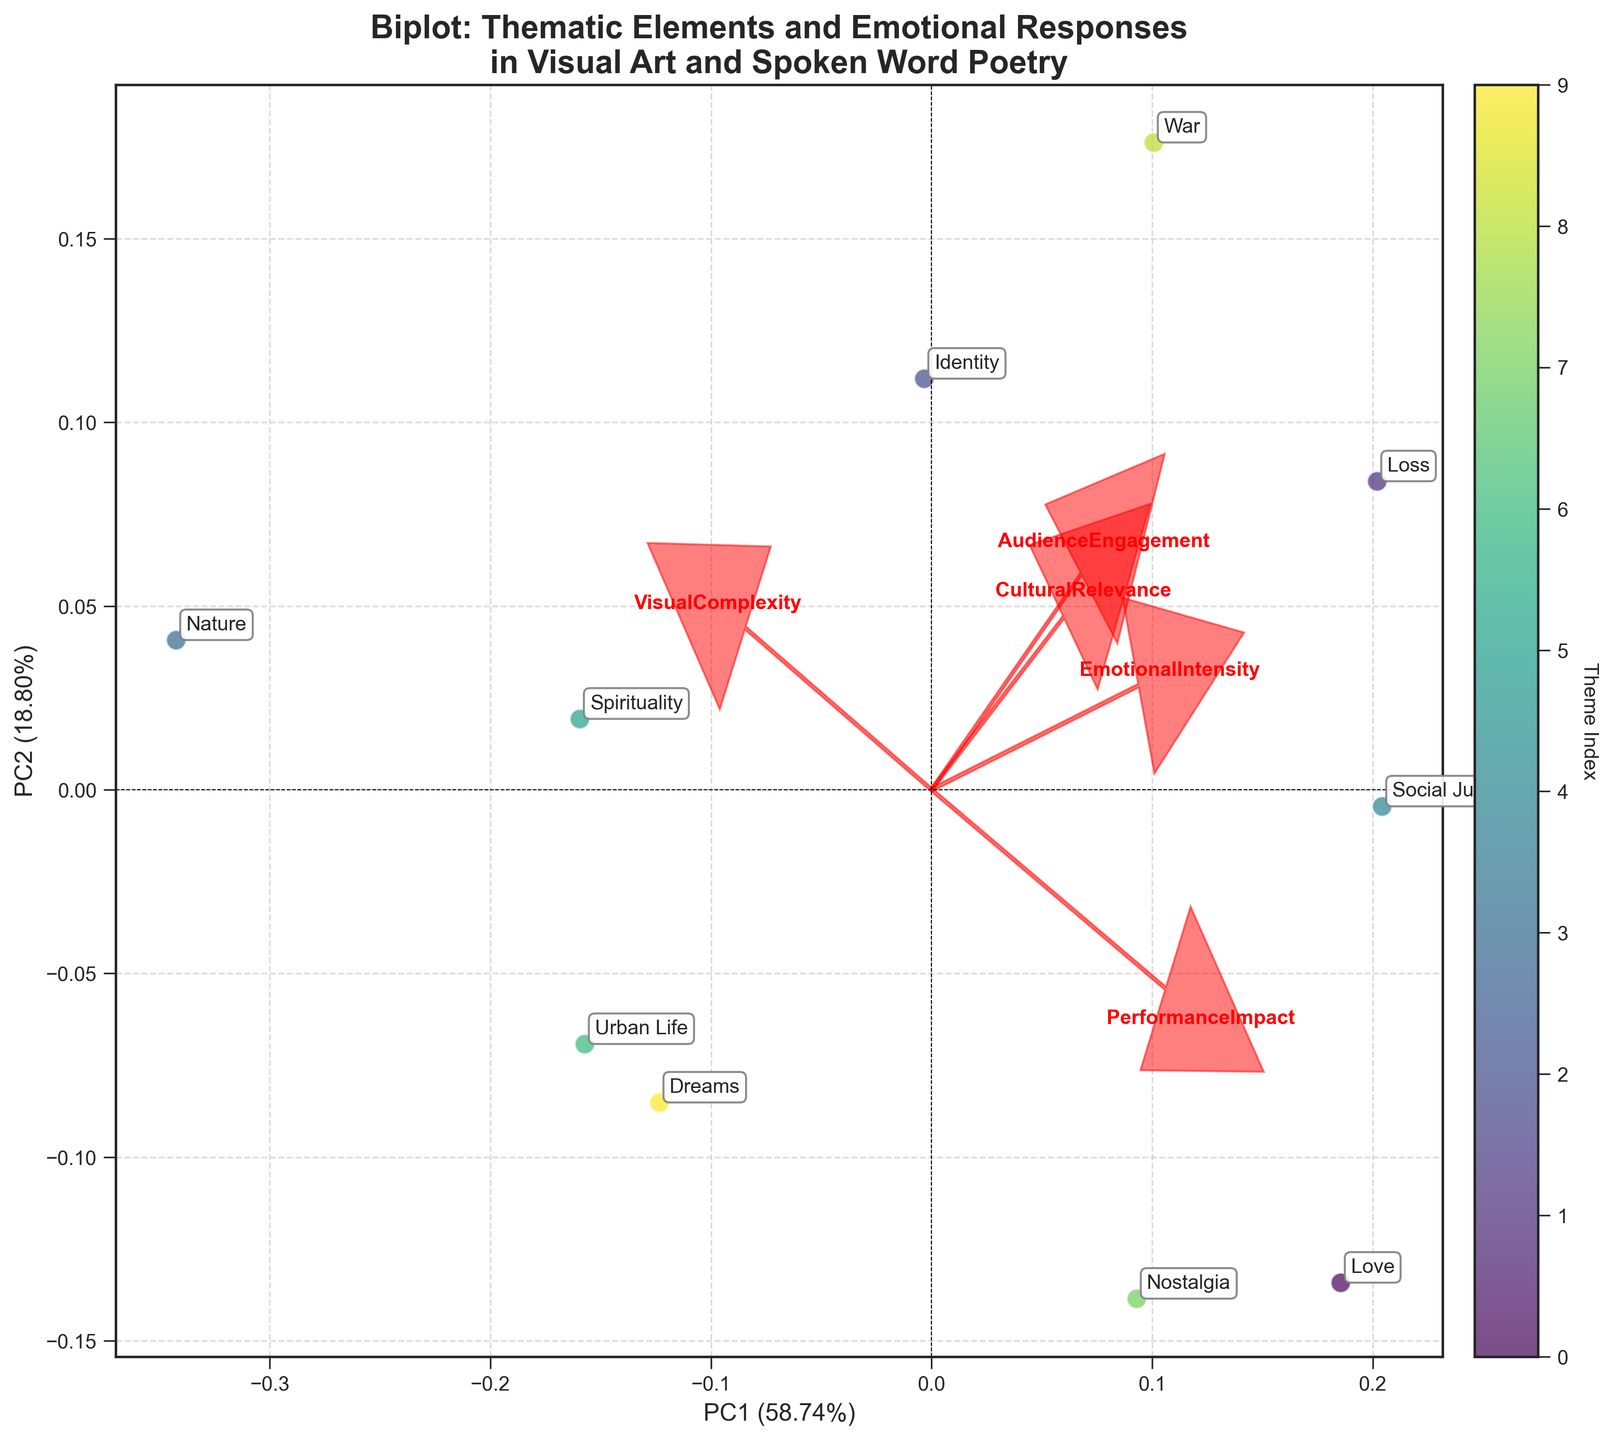How many thematic elements are represented in the biplot? Count the number of unique labels annotated in the plot, each representing a thematic element.
Answer: 10 What theme has the highest Performance Impact? Look at the loading vectors in the plot labeled with 'PerformanceImpact' and find the data point closest in that direction.
Answer: Love Which theme is closest to the origin in the biplot? Identify the data point that is nearest to the (0,0) coordinate.
Answer: Urban Life What is the percentage of variance explained by the first principal component (PC1)? Refer to the x-axis label which shows the percentage of variance explained by PC1.
Answer: [Exact percentage from the plot] Which two themes are closest to each other in the biplot? Observe the scatter plot and identify the two points that are nearest to each other.
Answer: Spirituality and Identity How do the Emotional Intensity scores correlate with PC1 and PC2? Observe the arrow labeled 'EmotionalIntensity' and note its direction relative to PC1 and PC2 axes.
Answer: Positively correlates with PC1 and slightly with PC2 Which thematic element shows the highest Audience Engagement? Look at the loading vectors in the plot labeled with 'AudienceEngagement' and find the data point closest in that direction.
Answer: Loss What percentage of the total variance is explained by the second principal component (PC2)? Refer to the y-axis label which shows the percentage of variance explained by PC2.
Answer: [Exact percentage from the plot] Which theme has the highest visual complexity? Look at the loading vectors in the plot labeled with 'VisualComplexity' and find the data point closest in that direction.
Answer: Nature Is there a theme that has both high Cultural Relevance and high Emotional Intensity? Look at the thematic elements closest to the loadings labeled 'CulturalRelevance' and 'EmotionalIntensity' in their directions.
Answer: Loss 